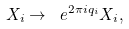<formula> <loc_0><loc_0><loc_500><loc_500>X _ { i } \to \ e ^ { 2 \pi i q _ { i } } X _ { i } ,</formula> 